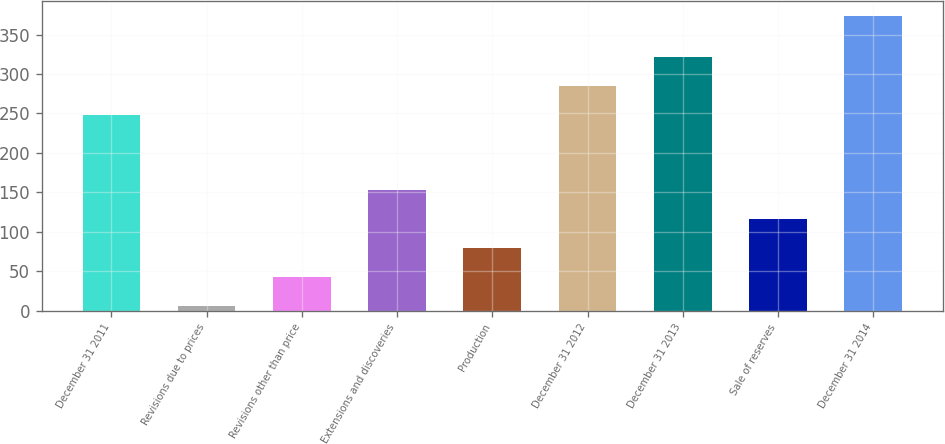Convert chart. <chart><loc_0><loc_0><loc_500><loc_500><bar_chart><fcel>December 31 2011<fcel>Revisions due to prices<fcel>Revisions other than price<fcel>Extensions and discoveries<fcel>Production<fcel>December 31 2012<fcel>December 31 2013<fcel>Sale of reserves<fcel>December 31 2014<nl><fcel>248<fcel>6<fcel>42.8<fcel>153.2<fcel>79.6<fcel>284.8<fcel>321.6<fcel>116.4<fcel>374<nl></chart> 